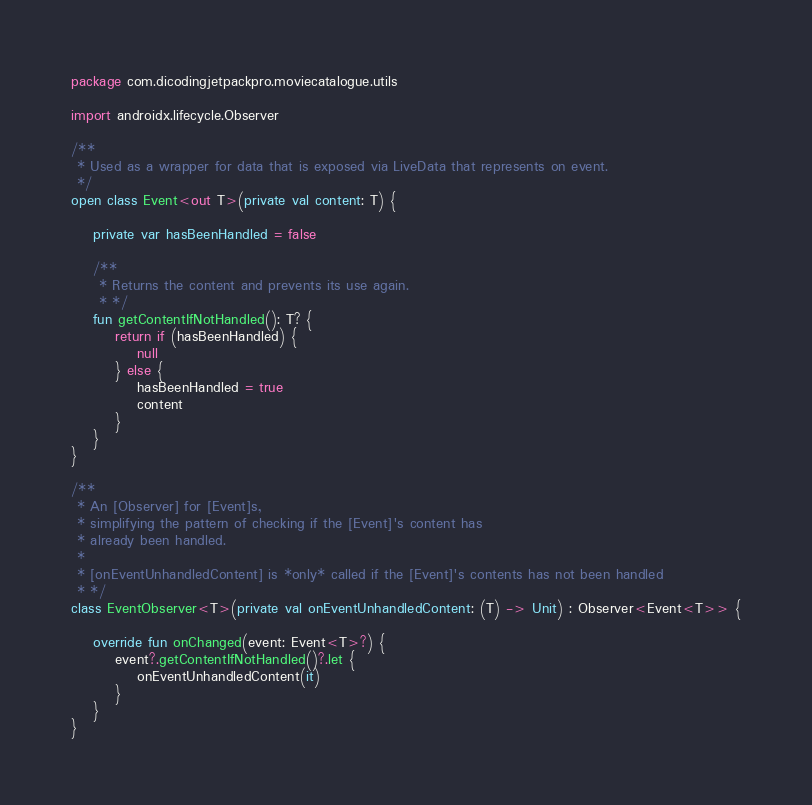<code> <loc_0><loc_0><loc_500><loc_500><_Kotlin_>package com.dicodingjetpackpro.moviecatalogue.utils

import androidx.lifecycle.Observer

/**
 * Used as a wrapper for data that is exposed via LiveData that represents on event.
 */
open class Event<out T>(private val content: T) {

    private var hasBeenHandled = false

    /**
     * Returns the content and prevents its use again.
     * */
    fun getContentIfNotHandled(): T? {
        return if (hasBeenHandled) {
            null
        } else {
            hasBeenHandled = true
            content
        }
    }
}

/**
 * An [Observer] for [Event]s,
 * simplifying the pattern of checking if the [Event]'s content has
 * already been handled.
 *
 * [onEventUnhandledContent] is *only* called if the [Event]'s contents has not been handled
 * */
class EventObserver<T>(private val onEventUnhandledContent: (T) -> Unit) : Observer<Event<T>> {

    override fun onChanged(event: Event<T>?) {
        event?.getContentIfNotHandled()?.let {
            onEventUnhandledContent(it)
        }
    }
}
</code> 